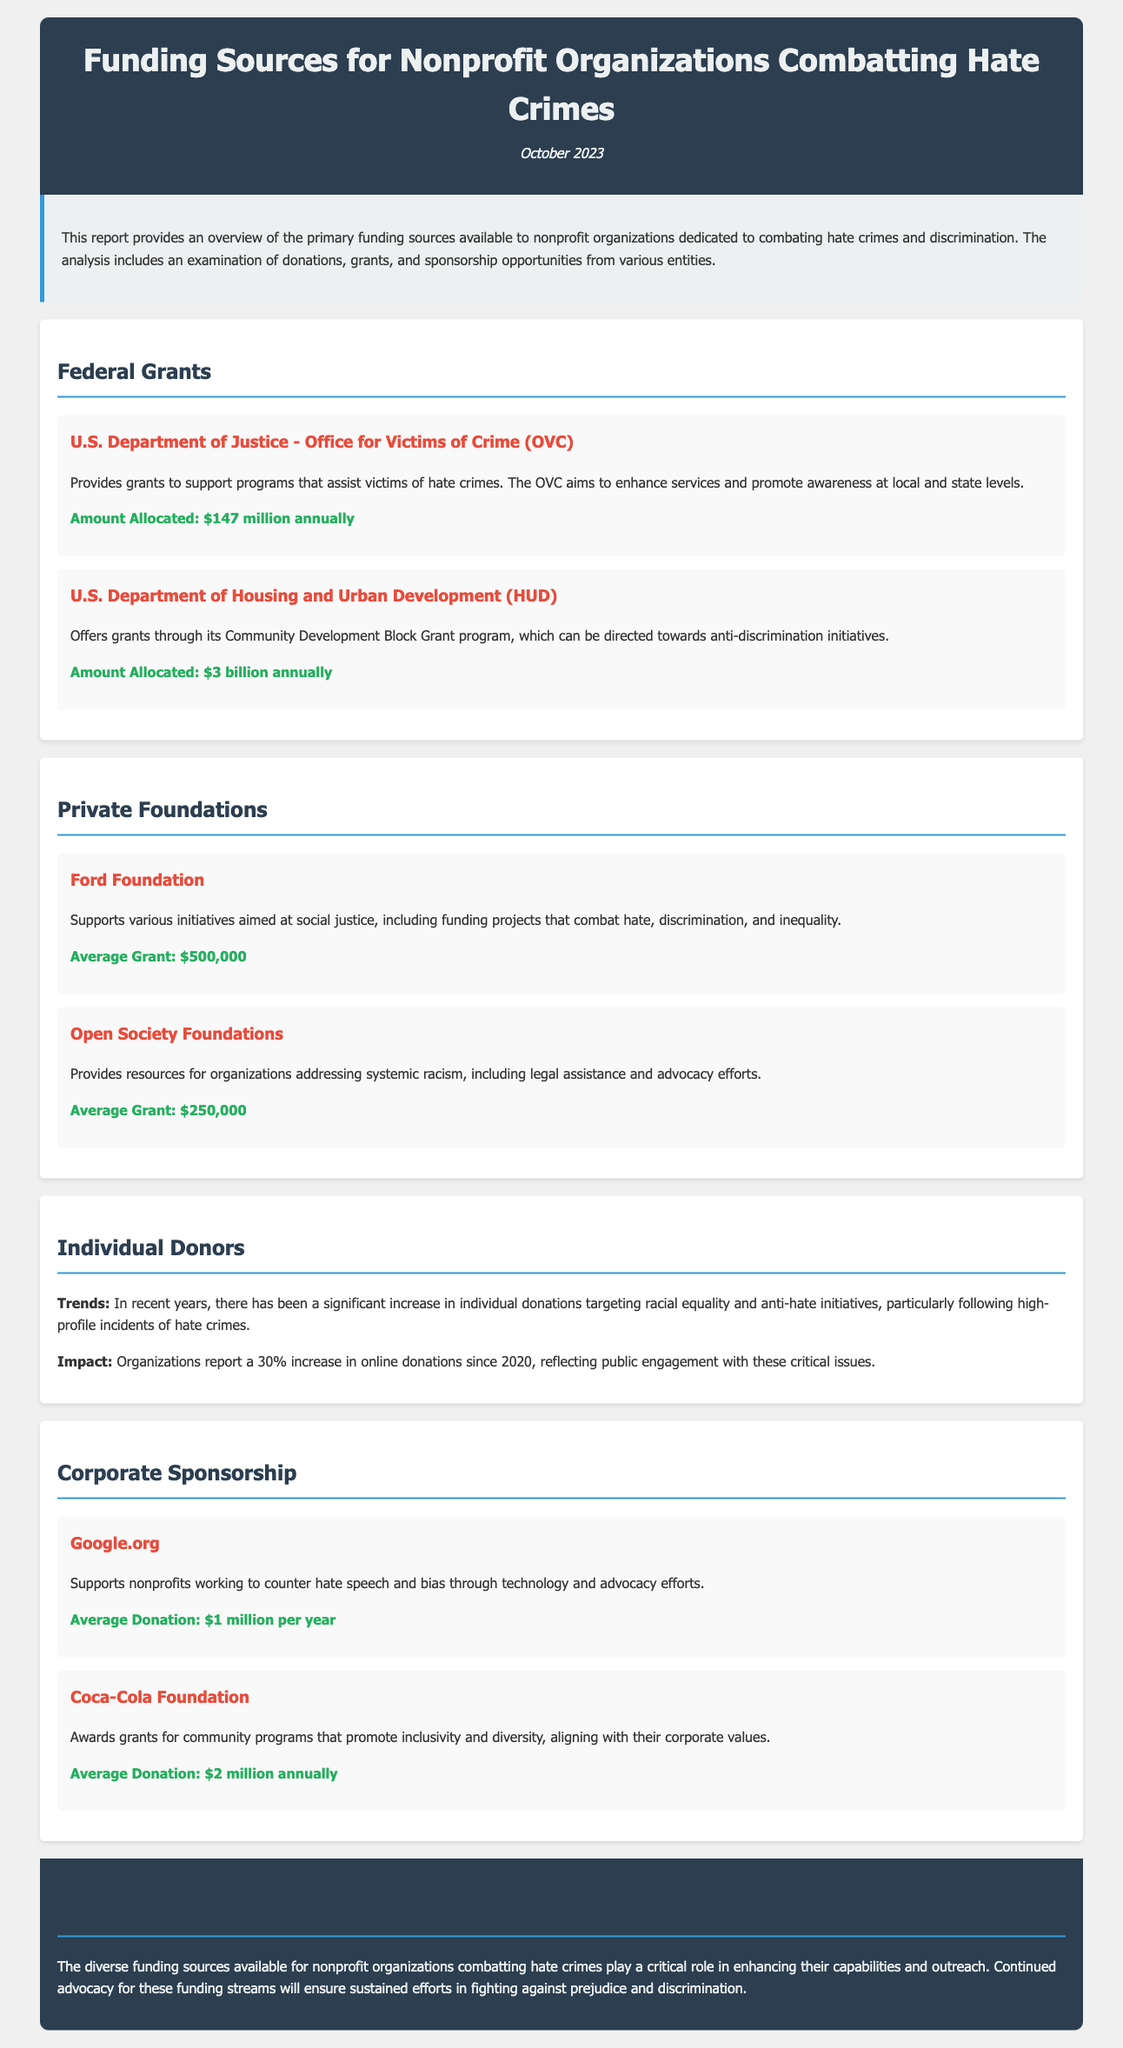What is the title of the report? The title of the report is mentioned in the header section.
Answer: Funding Sources for Nonprofit Organizations Combatting Hate Crimes What is the amount allocated by the U.S. Department of Justice - Office for Victims of Crime? The amount allocated is specifically listed under the federal grants section.
Answer: $147 million annually What average grant does the Ford Foundation provide? This information is found within the private foundations section regarding funding sources.
Answer: $500,000 How much is the average donation from Google.org? The average donation is indicated in the corporate sponsorship section.
Answer: $1 million per year What trend is observed in individual donations since 2020? The document notes this trend in the section discussing individual donors.
Answer: 30% increase What is the total amount allocated by the U.S. Department of Housing and Urban Development? The total amount is provided in the federal grants section for HUD.
Answer: $3 billion annually Which foundation supports initiatives aimed at addressing systemic racism? This information can be found in the funding source descriptions under private foundations.
Answer: Open Society Foundations What type of programs does the Coca-Cola Foundation support? The document provides a brief description of the Coca-Cola Foundation's focus within corporate sponsorship.
Answer: Community programs that promote inclusivity and diversity 